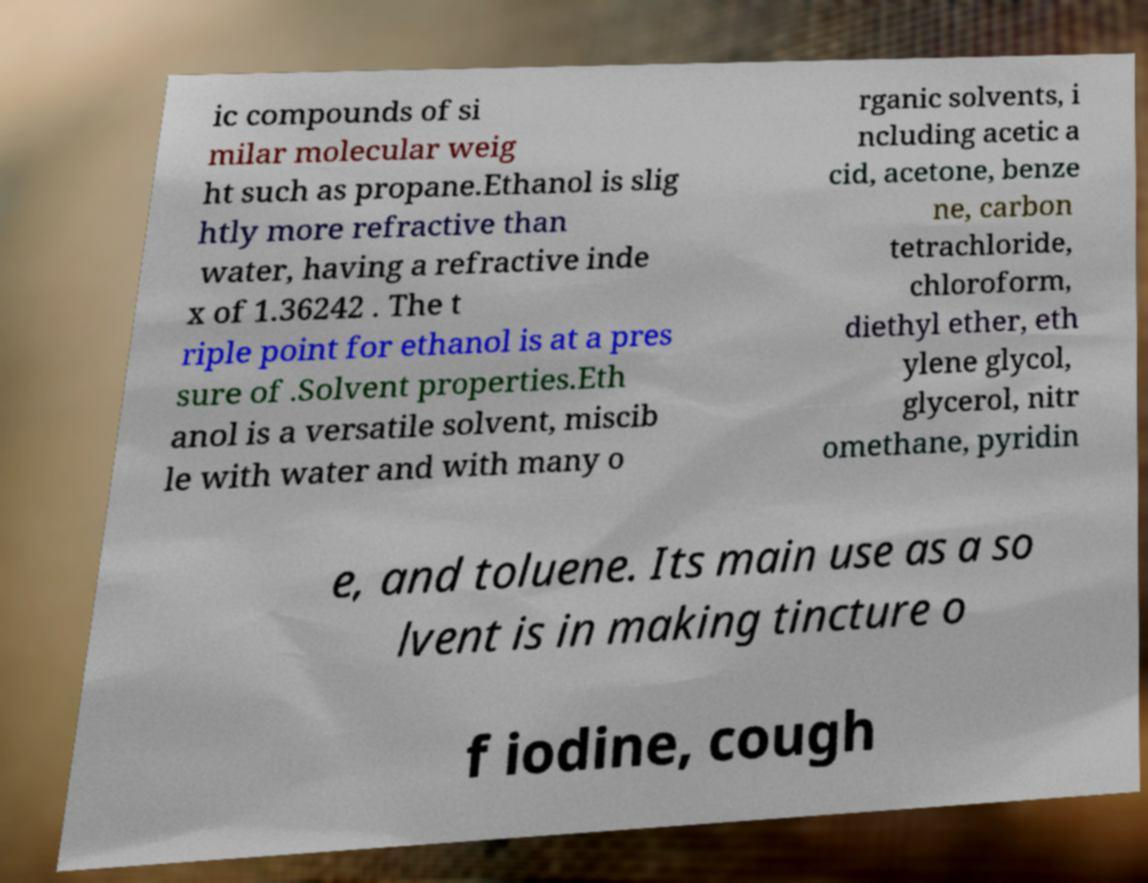For documentation purposes, I need the text within this image transcribed. Could you provide that? ic compounds of si milar molecular weig ht such as propane.Ethanol is slig htly more refractive than water, having a refractive inde x of 1.36242 . The t riple point for ethanol is at a pres sure of .Solvent properties.Eth anol is a versatile solvent, miscib le with water and with many o rganic solvents, i ncluding acetic a cid, acetone, benze ne, carbon tetrachloride, chloroform, diethyl ether, eth ylene glycol, glycerol, nitr omethane, pyridin e, and toluene. Its main use as a so lvent is in making tincture o f iodine, cough 